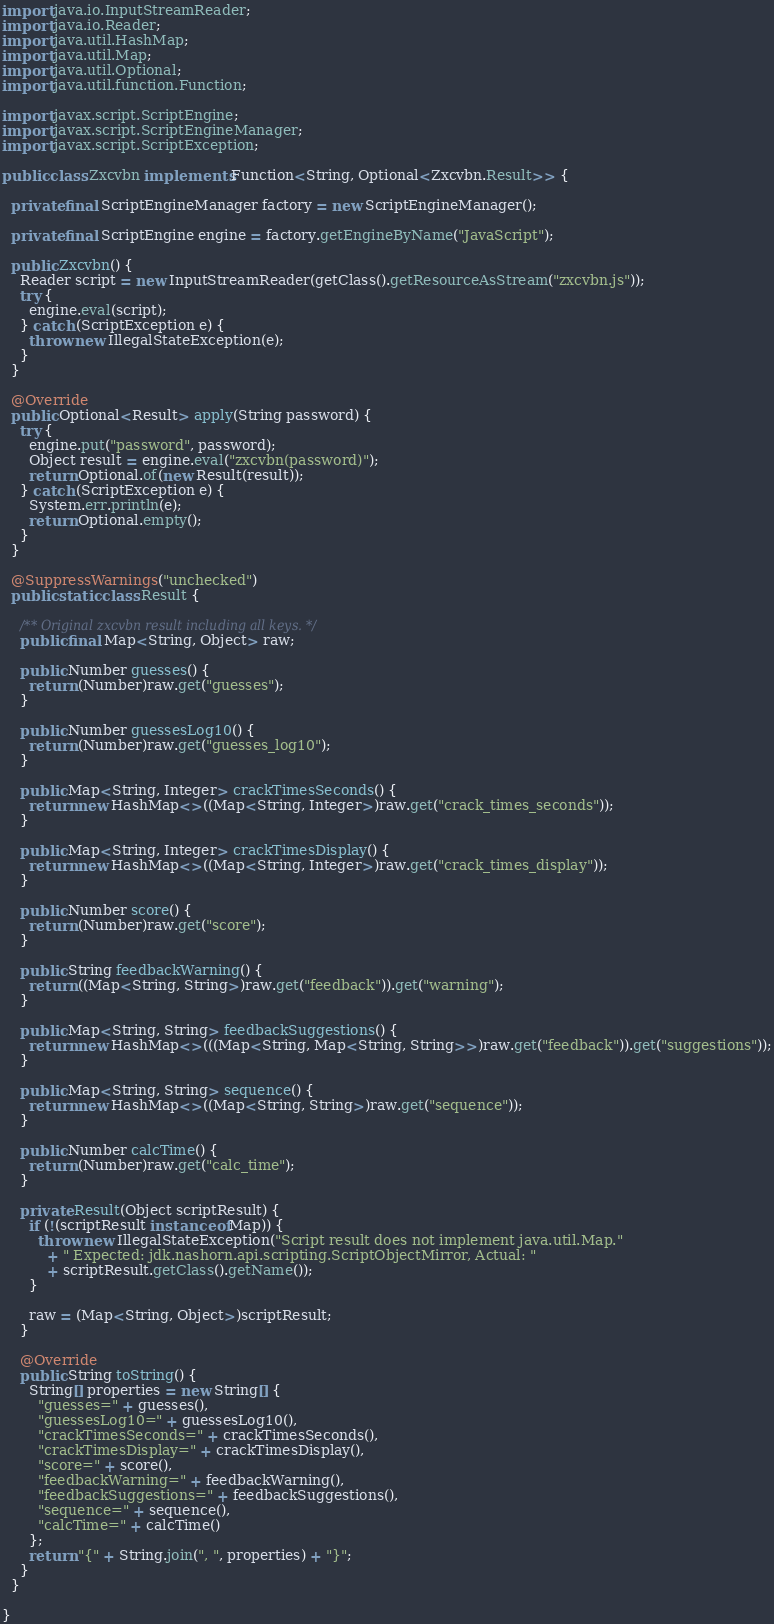<code> <loc_0><loc_0><loc_500><loc_500><_Java_>import java.io.InputStreamReader;
import java.io.Reader;
import java.util.HashMap;
import java.util.Map;
import java.util.Optional;
import java.util.function.Function;

import javax.script.ScriptEngine;
import javax.script.ScriptEngineManager;
import javax.script.ScriptException;

public class Zxcvbn implements Function<String, Optional<Zxcvbn.Result>> {

  private final ScriptEngineManager factory = new ScriptEngineManager();

  private final ScriptEngine engine = factory.getEngineByName("JavaScript");

  public Zxcvbn() {
    Reader script = new InputStreamReader(getClass().getResourceAsStream("zxcvbn.js"));
    try {
      engine.eval(script);
    } catch (ScriptException e) {
      throw new IllegalStateException(e);
    }
  }

  @Override
  public Optional<Result> apply(String password) {
    try {
      engine.put("password", password);
      Object result = engine.eval("zxcvbn(password)");
      return Optional.of(new Result(result));
    } catch (ScriptException e) {
      System.err.println(e);
      return Optional.empty();
    }
  }

  @SuppressWarnings("unchecked")
  public static class Result {

    /** Original zxcvbn result including all keys. */
    public final Map<String, Object> raw;

    public Number guesses() {
      return (Number)raw.get("guesses");
    }

    public Number guessesLog10() {
      return (Number)raw.get("guesses_log10");
    }

    public Map<String, Integer> crackTimesSeconds() {
      return new HashMap<>((Map<String, Integer>)raw.get("crack_times_seconds"));
    }

    public Map<String, Integer> crackTimesDisplay() {
      return new HashMap<>((Map<String, Integer>)raw.get("crack_times_display"));
    }

    public Number score() {
      return (Number)raw.get("score");
    }

    public String feedbackWarning() {
      return ((Map<String, String>)raw.get("feedback")).get("warning");
    }

    public Map<String, String> feedbackSuggestions() {
      return new HashMap<>(((Map<String, Map<String, String>>)raw.get("feedback")).get("suggestions"));
    }

    public Map<String, String> sequence() {
      return new HashMap<>((Map<String, String>)raw.get("sequence"));
    }

    public Number calcTime() {
      return (Number)raw.get("calc_time");
    }

    private Result(Object scriptResult) {
      if (!(scriptResult instanceof Map)) {
        throw new IllegalStateException("Script result does not implement java.util.Map."
          + " Expected: jdk.nashorn.api.scripting.ScriptObjectMirror, Actual: "
          + scriptResult.getClass().getName());
      }

      raw = (Map<String, Object>)scriptResult;
    }

    @Override
    public String toString() {
      String[] properties = new String[] {
        "guesses=" + guesses(),
        "guessesLog10=" + guessesLog10(),
        "crackTimesSeconds=" + crackTimesSeconds(),
        "crackTimesDisplay=" + crackTimesDisplay(),
        "score=" + score(),
        "feedbackWarning=" + feedbackWarning(),
        "feedbackSuggestions=" + feedbackSuggestions(),
        "sequence=" + sequence(),
        "calcTime=" + calcTime()
      };
      return "{" + String.join(", ", properties) + "}";
    }
  }

}
</code> 